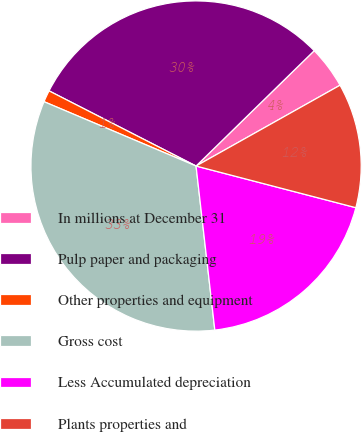Convert chart. <chart><loc_0><loc_0><loc_500><loc_500><pie_chart><fcel>In millions at December 31<fcel>Pulp paper and packaging<fcel>Other properties and equipment<fcel>Gross cost<fcel>Less Accumulated depreciation<fcel>Plants properties and<nl><fcel>4.17%<fcel>30.17%<fcel>1.15%<fcel>33.19%<fcel>19.13%<fcel>12.2%<nl></chart> 